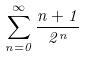Convert formula to latex. <formula><loc_0><loc_0><loc_500><loc_500>\sum _ { n = 0 } ^ { \infty } \frac { n + 1 } { 2 ^ { n } }</formula> 